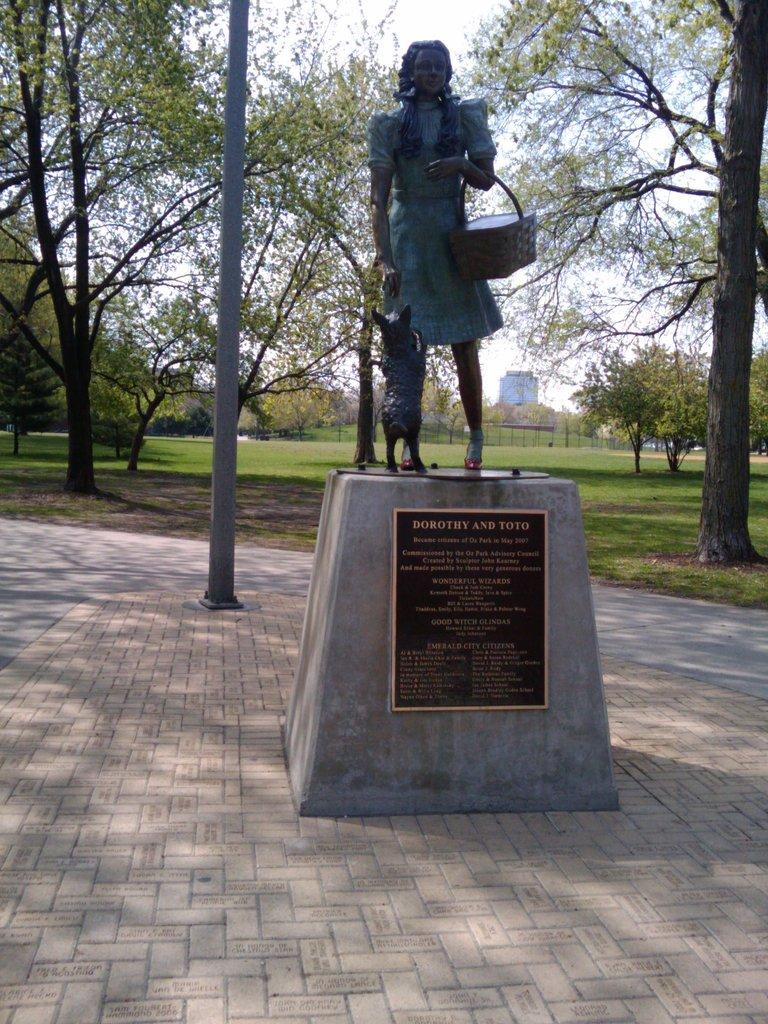What is the main subject of the image? There is a statue at the center of the image. What is located behind the statue? There is a pole behind the statue. What is visible behind the pole? There is a road behind the pole. What type of surface is present in the image? Grass is present on the surface. What can be seen in the background of the image? There are trees, a building, and the sky visible in the background of the image. What type of credit card is being used to purchase the statue in the image? There is no credit card or purchase activity depicted in the image; it simply shows a statue with surrounding elements. 